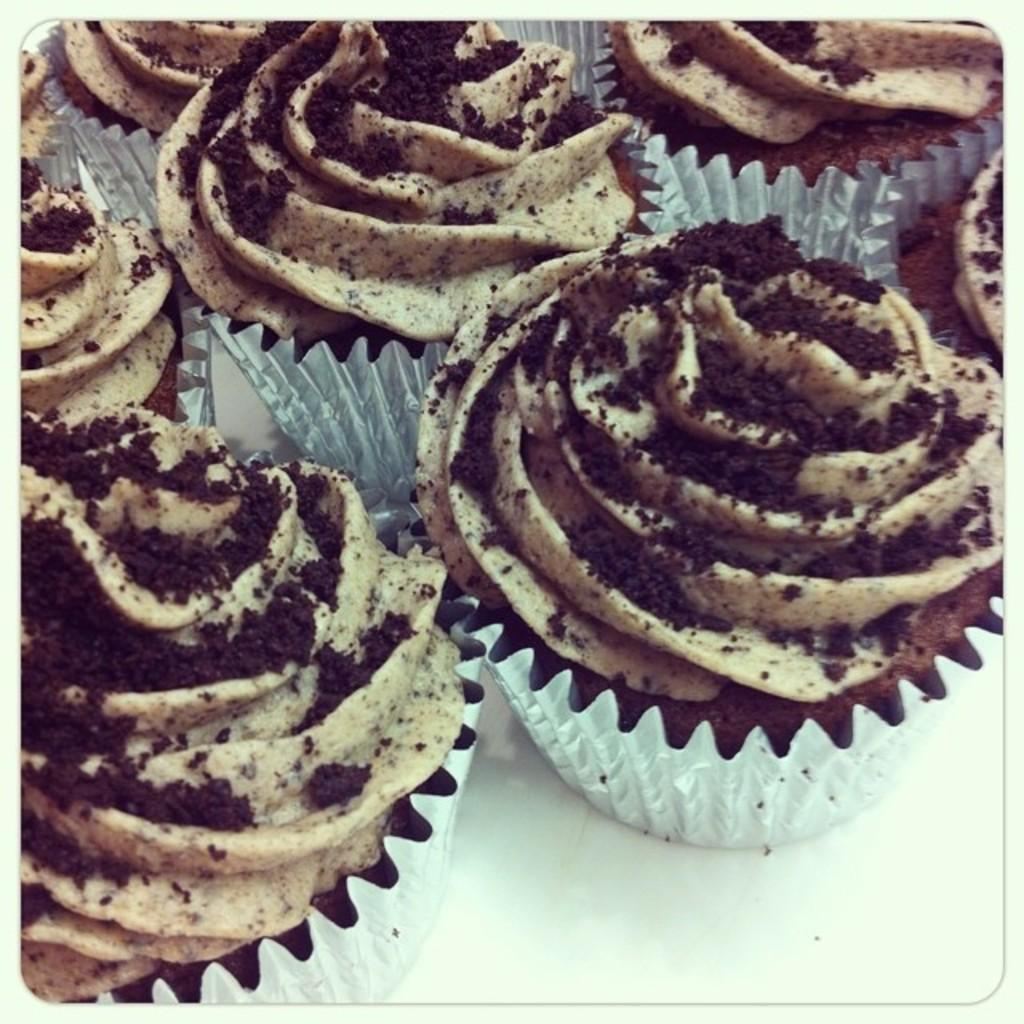What type of cupcakes are in the image? There are chocolate cupcakes in the image. Where are the chocolate cupcakes placed? The chocolate cupcakes are placed on a white table top. What type of record can be seen playing on the turntable in the image? There is no turntable or record present in the image; it only features chocolate cupcakes on a white table top. 